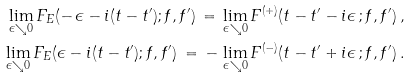Convert formula to latex. <formula><loc_0><loc_0><loc_500><loc_500>\lim _ { \epsilon \searrow 0 } F _ { E } ( - \, \epsilon - i ( t - t ^ { \prime } ) ; f , f ^ { \prime } ) \, = \, \lim _ { \epsilon \searrow 0 } F ^ { ( + ) } ( t - t ^ { \prime } - i \epsilon \, ; f , f ^ { \prime } ) \, , \\ \lim _ { \epsilon \searrow 0 } F _ { E } ( \epsilon - i ( t - t ^ { \prime } ) ; f , f ^ { \prime } ) \, = \, - \, \lim _ { \epsilon \searrow 0 } F ^ { ( - ) } ( t - t ^ { \prime } + i \epsilon \, ; f , f ^ { \prime } ) \, .</formula> 